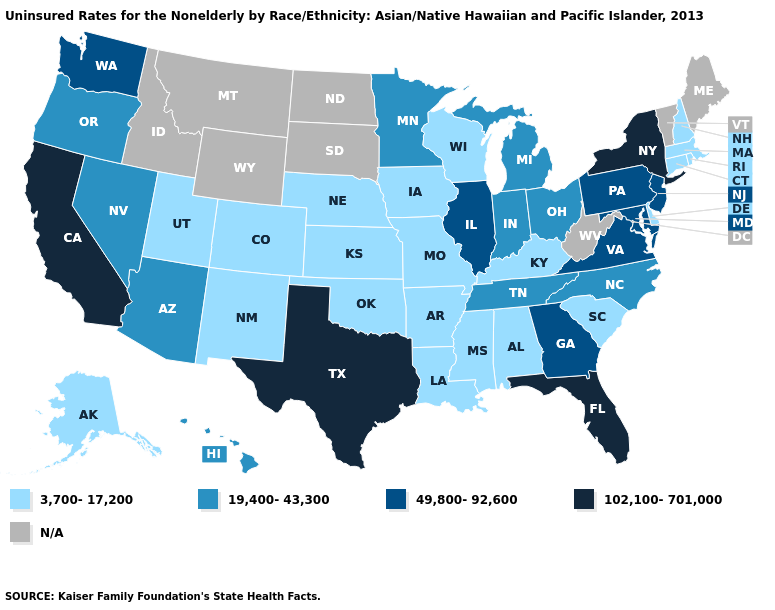Name the states that have a value in the range 49,800-92,600?
Quick response, please. Georgia, Illinois, Maryland, New Jersey, Pennsylvania, Virginia, Washington. What is the value of Iowa?
Quick response, please. 3,700-17,200. What is the highest value in the MidWest ?
Answer briefly. 49,800-92,600. What is the lowest value in states that border Nevada?
Short answer required. 3,700-17,200. Does the first symbol in the legend represent the smallest category?
Be succinct. Yes. Which states have the lowest value in the South?
Quick response, please. Alabama, Arkansas, Delaware, Kentucky, Louisiana, Mississippi, Oklahoma, South Carolina. What is the highest value in states that border Kentucky?
Answer briefly. 49,800-92,600. What is the lowest value in the Northeast?
Answer briefly. 3,700-17,200. What is the value of Oklahoma?
Short answer required. 3,700-17,200. What is the value of Hawaii?
Keep it brief. 19,400-43,300. What is the value of Alaska?
Quick response, please. 3,700-17,200. Does the map have missing data?
Keep it brief. Yes. Name the states that have a value in the range N/A?
Write a very short answer. Idaho, Maine, Montana, North Dakota, South Dakota, Vermont, West Virginia, Wyoming. Does New Hampshire have the highest value in the Northeast?
Write a very short answer. No. 